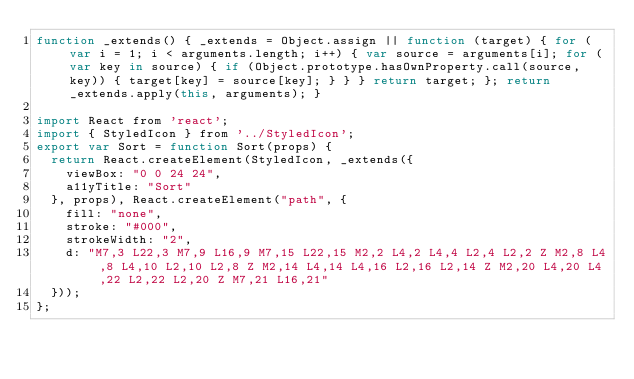Convert code to text. <code><loc_0><loc_0><loc_500><loc_500><_JavaScript_>function _extends() { _extends = Object.assign || function (target) { for (var i = 1; i < arguments.length; i++) { var source = arguments[i]; for (var key in source) { if (Object.prototype.hasOwnProperty.call(source, key)) { target[key] = source[key]; } } } return target; }; return _extends.apply(this, arguments); }

import React from 'react';
import { StyledIcon } from '../StyledIcon';
export var Sort = function Sort(props) {
  return React.createElement(StyledIcon, _extends({
    viewBox: "0 0 24 24",
    a11yTitle: "Sort"
  }, props), React.createElement("path", {
    fill: "none",
    stroke: "#000",
    strokeWidth: "2",
    d: "M7,3 L22,3 M7,9 L16,9 M7,15 L22,15 M2,2 L4,2 L4,4 L2,4 L2,2 Z M2,8 L4,8 L4,10 L2,10 L2,8 Z M2,14 L4,14 L4,16 L2,16 L2,14 Z M2,20 L4,20 L4,22 L2,22 L2,20 Z M7,21 L16,21"
  }));
};</code> 